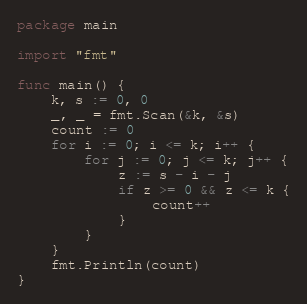<code> <loc_0><loc_0><loc_500><loc_500><_Go_>package main

import "fmt"

func main() {
	k, s := 0, 0
	_, _ = fmt.Scan(&k, &s)
	count := 0
	for i := 0; i <= k; i++ {
		for j := 0; j <= k; j++ {
			z := s - i - j
			if z >= 0 && z <= k {
				count++
			}
		}
	}
	fmt.Println(count)
}</code> 